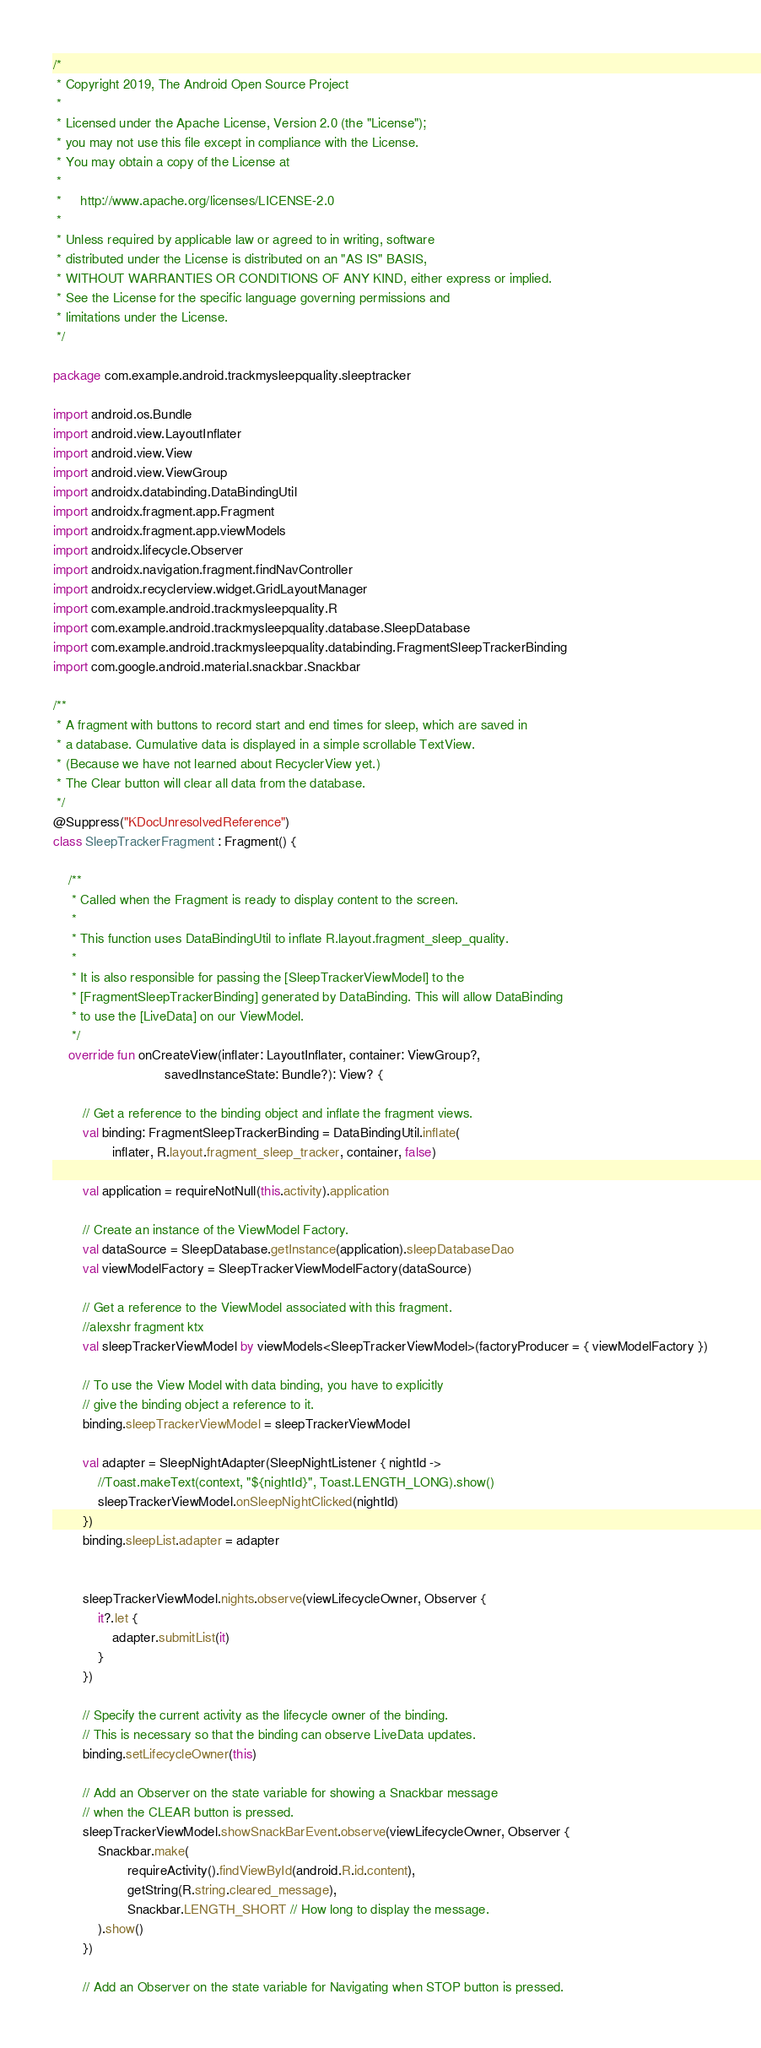<code> <loc_0><loc_0><loc_500><loc_500><_Kotlin_>/*
 * Copyright 2019, The Android Open Source Project
 *
 * Licensed under the Apache License, Version 2.0 (the "License");
 * you may not use this file except in compliance with the License.
 * You may obtain a copy of the License at
 *
 *     http://www.apache.org/licenses/LICENSE-2.0
 *
 * Unless required by applicable law or agreed to in writing, software
 * distributed under the License is distributed on an "AS IS" BASIS,
 * WITHOUT WARRANTIES OR CONDITIONS OF ANY KIND, either express or implied.
 * See the License for the specific language governing permissions and
 * limitations under the License.
 */

package com.example.android.trackmysleepquality.sleeptracker

import android.os.Bundle
import android.view.LayoutInflater
import android.view.View
import android.view.ViewGroup
import androidx.databinding.DataBindingUtil
import androidx.fragment.app.Fragment
import androidx.fragment.app.viewModels
import androidx.lifecycle.Observer
import androidx.navigation.fragment.findNavController
import androidx.recyclerview.widget.GridLayoutManager
import com.example.android.trackmysleepquality.R
import com.example.android.trackmysleepquality.database.SleepDatabase
import com.example.android.trackmysleepquality.databinding.FragmentSleepTrackerBinding
import com.google.android.material.snackbar.Snackbar

/**
 * A fragment with buttons to record start and end times for sleep, which are saved in
 * a database. Cumulative data is displayed in a simple scrollable TextView.
 * (Because we have not learned about RecyclerView yet.)
 * The Clear button will clear all data from the database.
 */
@Suppress("KDocUnresolvedReference")
class SleepTrackerFragment : Fragment() {

    /**
     * Called when the Fragment is ready to display content to the screen.
     *
     * This function uses DataBindingUtil to inflate R.layout.fragment_sleep_quality.
     *
     * It is also responsible for passing the [SleepTrackerViewModel] to the
     * [FragmentSleepTrackerBinding] generated by DataBinding. This will allow DataBinding
     * to use the [LiveData] on our ViewModel.
     */
    override fun onCreateView(inflater: LayoutInflater, container: ViewGroup?,
                              savedInstanceState: Bundle?): View? {

        // Get a reference to the binding object and inflate the fragment views.
        val binding: FragmentSleepTrackerBinding = DataBindingUtil.inflate(
                inflater, R.layout.fragment_sleep_tracker, container, false)

        val application = requireNotNull(this.activity).application

        // Create an instance of the ViewModel Factory.
        val dataSource = SleepDatabase.getInstance(application).sleepDatabaseDao
        val viewModelFactory = SleepTrackerViewModelFactory(dataSource)

        // Get a reference to the ViewModel associated with this fragment.
        //alexshr fragment ktx
        val sleepTrackerViewModel by viewModels<SleepTrackerViewModel>(factoryProducer = { viewModelFactory })

        // To use the View Model with data binding, you have to explicitly
        // give the binding object a reference to it.
        binding.sleepTrackerViewModel = sleepTrackerViewModel

        val adapter = SleepNightAdapter(SleepNightListener { nightId ->
            //Toast.makeText(context, "${nightId}", Toast.LENGTH_LONG).show()
            sleepTrackerViewModel.onSleepNightClicked(nightId)
        })
        binding.sleepList.adapter = adapter


        sleepTrackerViewModel.nights.observe(viewLifecycleOwner, Observer {
            it?.let {
                adapter.submitList(it)
            }
        })

        // Specify the current activity as the lifecycle owner of the binding.
        // This is necessary so that the binding can observe LiveData updates.
        binding.setLifecycleOwner(this)

        // Add an Observer on the state variable for showing a Snackbar message
        // when the CLEAR button is pressed.
        sleepTrackerViewModel.showSnackBarEvent.observe(viewLifecycleOwner, Observer {
            Snackbar.make(
                    requireActivity().findViewById(android.R.id.content),
                    getString(R.string.cleared_message),
                    Snackbar.LENGTH_SHORT // How long to display the message.
            ).show()
        })

        // Add an Observer on the state variable for Navigating when STOP button is pressed.</code> 